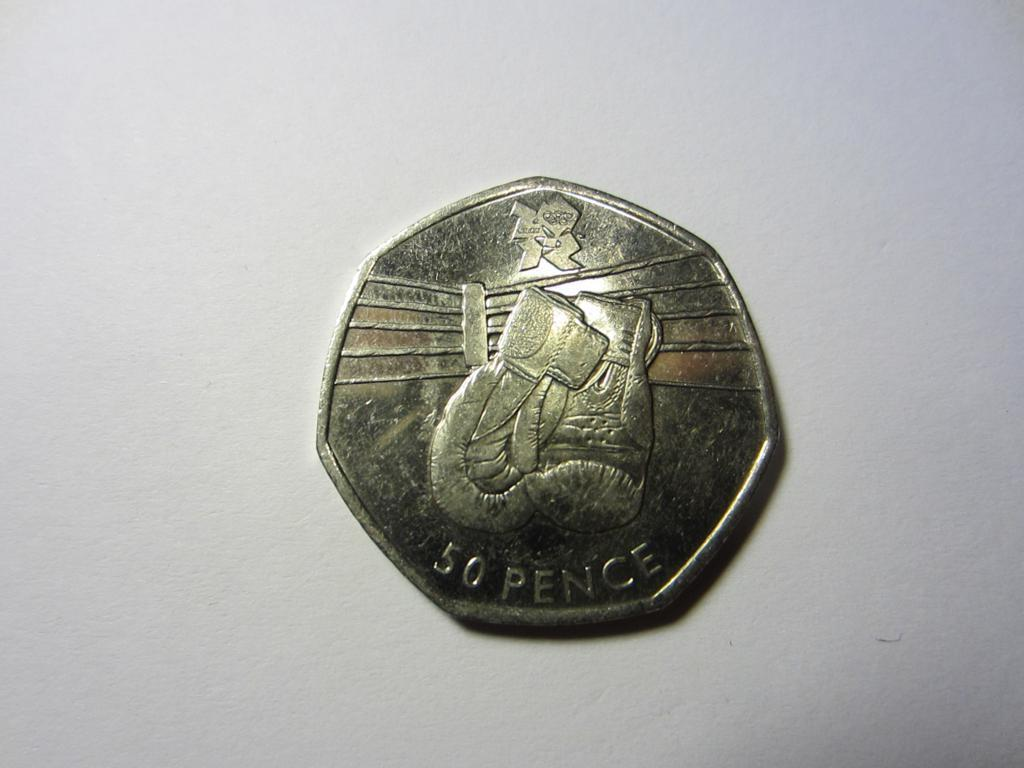<image>
Share a concise interpretation of the image provided. 50 Pence is etched onto the bottom of this coin. 